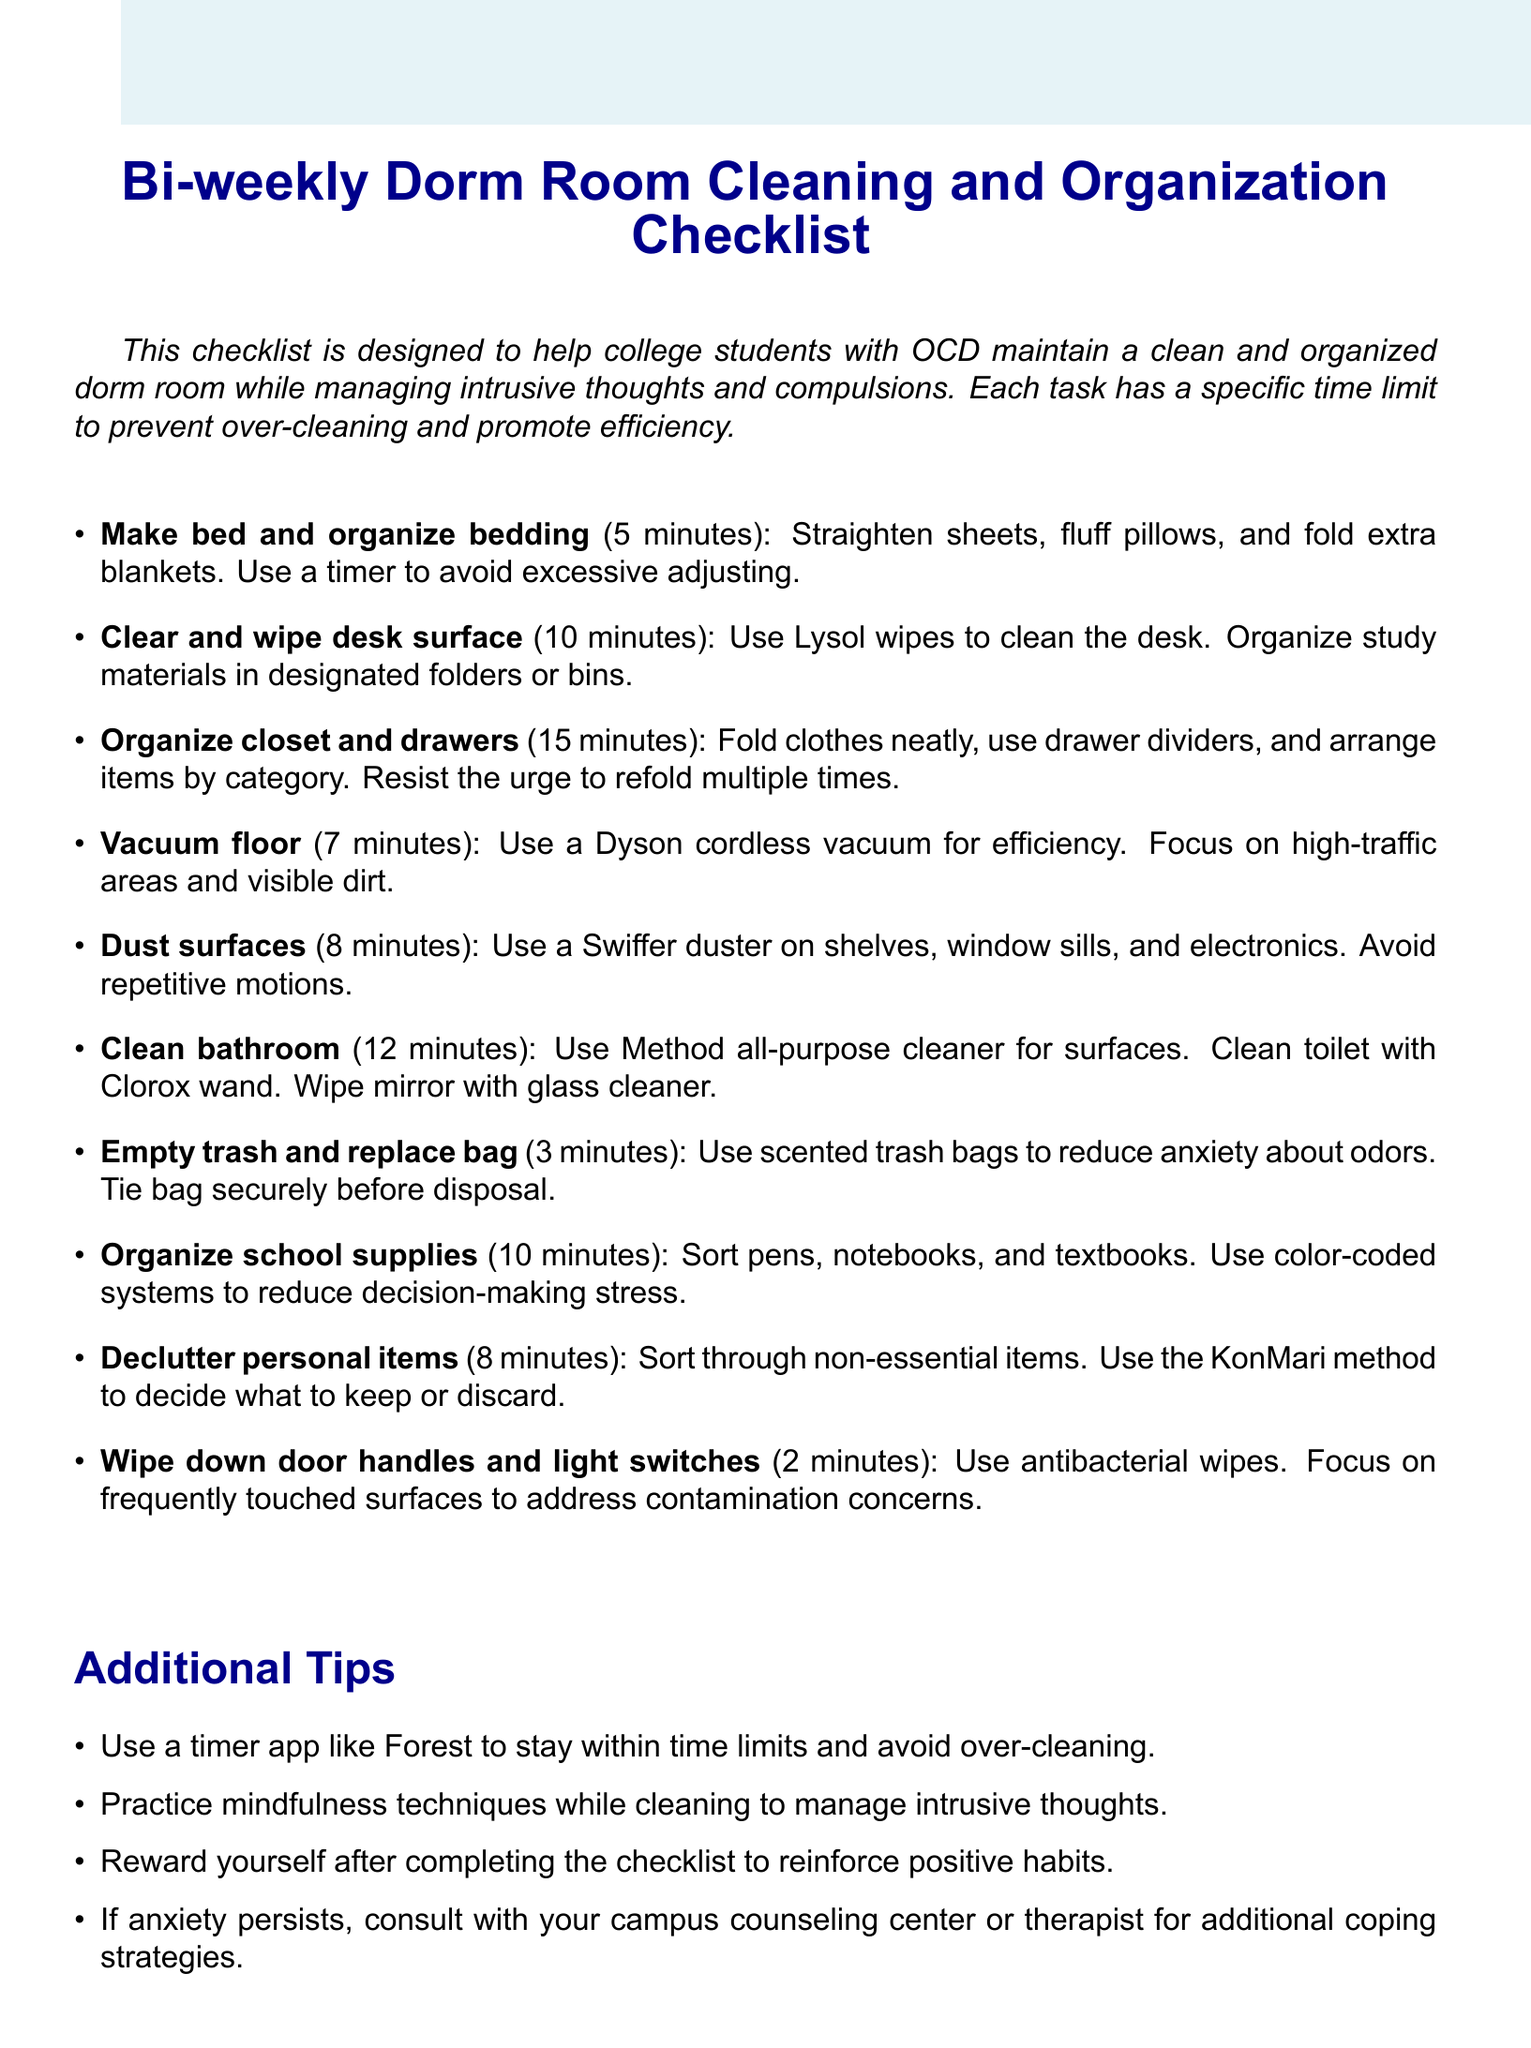What is the title of the checklist? The title specifies the main focus of the document, which is designed for dorm room cleaning and organization.
Answer: Bi-weekly Dorm Room Cleaning and Organization Checklist for OCD Management What is the time limit for making the bed? This task is listed in the checklist with a specific time to prevent over-cleaning.
Answer: 5 minutes Which product is recommended for cleaning the desk? The checklist includes a specific product to be used for cleaning the desk surface.
Answer: Lysol Disinfecting Wipes How long should you spend organizing the closet and drawers? This detail helps manage time during the cleaning process.
Answer: 15 minutes What method is suggested for decluttering personal items? The checklist provides a specific method to help with sorting personal belongings.
Answer: KonMari method What type of timer app is recommended? This information helps students manage their time effectively during cleaning.
Answer: Forest How long is the allotted time for wiping down door handles and light switches? This task has a designated short time limit to prevent prolonging the cleaning process.
Answer: 2 minutes What should you do if anxiety persists after using this checklist? This question addresses a concern that may arise while following the checklist.
Answer: Consult with your campus counseling center or therapist for additional coping strategies 